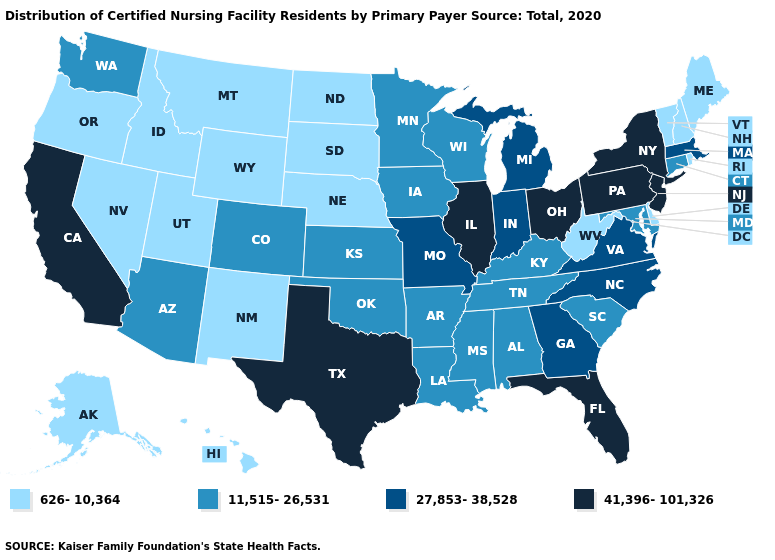What is the value of Florida?
Give a very brief answer. 41,396-101,326. Name the states that have a value in the range 41,396-101,326?
Concise answer only. California, Florida, Illinois, New Jersey, New York, Ohio, Pennsylvania, Texas. Does South Carolina have the same value as Idaho?
Answer briefly. No. Which states have the lowest value in the USA?
Quick response, please. Alaska, Delaware, Hawaii, Idaho, Maine, Montana, Nebraska, Nevada, New Hampshire, New Mexico, North Dakota, Oregon, Rhode Island, South Dakota, Utah, Vermont, West Virginia, Wyoming. Does Texas have the highest value in the USA?
Keep it brief. Yes. What is the value of Wyoming?
Short answer required. 626-10,364. Name the states that have a value in the range 626-10,364?
Answer briefly. Alaska, Delaware, Hawaii, Idaho, Maine, Montana, Nebraska, Nevada, New Hampshire, New Mexico, North Dakota, Oregon, Rhode Island, South Dakota, Utah, Vermont, West Virginia, Wyoming. Is the legend a continuous bar?
Quick response, please. No. Which states have the lowest value in the USA?
Be succinct. Alaska, Delaware, Hawaii, Idaho, Maine, Montana, Nebraska, Nevada, New Hampshire, New Mexico, North Dakota, Oregon, Rhode Island, South Dakota, Utah, Vermont, West Virginia, Wyoming. What is the lowest value in the USA?
Concise answer only. 626-10,364. Which states have the lowest value in the USA?
Quick response, please. Alaska, Delaware, Hawaii, Idaho, Maine, Montana, Nebraska, Nevada, New Hampshire, New Mexico, North Dakota, Oregon, Rhode Island, South Dakota, Utah, Vermont, West Virginia, Wyoming. What is the highest value in the USA?
Quick response, please. 41,396-101,326. Does South Dakota have the highest value in the MidWest?
Short answer required. No. Name the states that have a value in the range 27,853-38,528?
Be succinct. Georgia, Indiana, Massachusetts, Michigan, Missouri, North Carolina, Virginia. Does the map have missing data?
Quick response, please. No. 